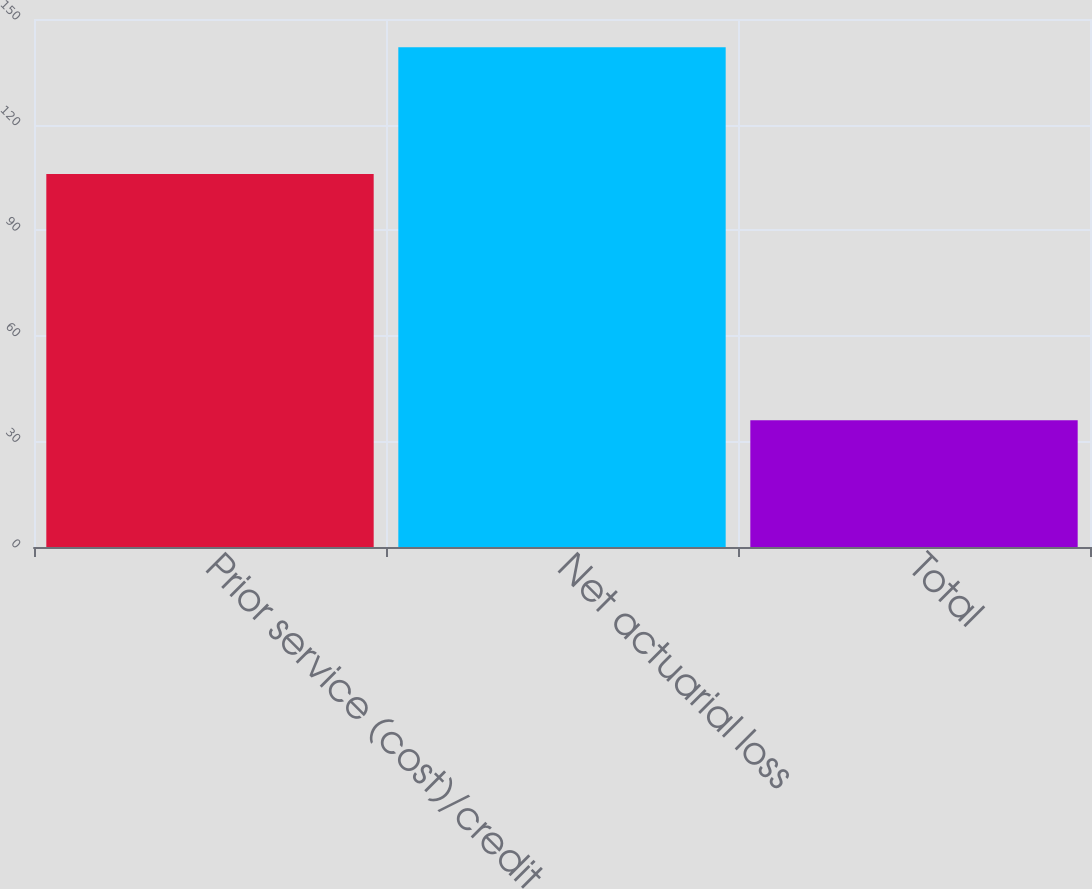<chart> <loc_0><loc_0><loc_500><loc_500><bar_chart><fcel>Prior service (cost)/credit<fcel>Net actuarial loss<fcel>Total<nl><fcel>106<fcel>142<fcel>36<nl></chart> 